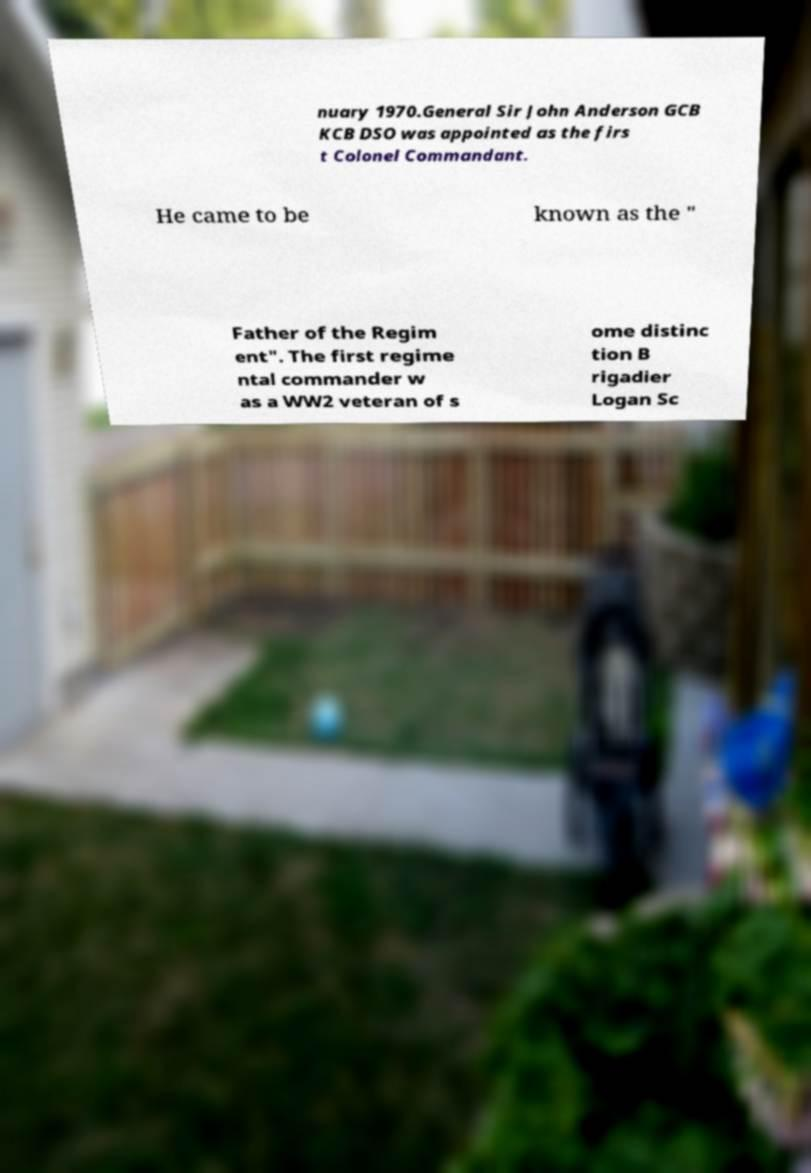Please read and relay the text visible in this image. What does it say? nuary 1970.General Sir John Anderson GCB KCB DSO was appointed as the firs t Colonel Commandant. He came to be known as the " Father of the Regim ent". The first regime ntal commander w as a WW2 veteran of s ome distinc tion B rigadier Logan Sc 